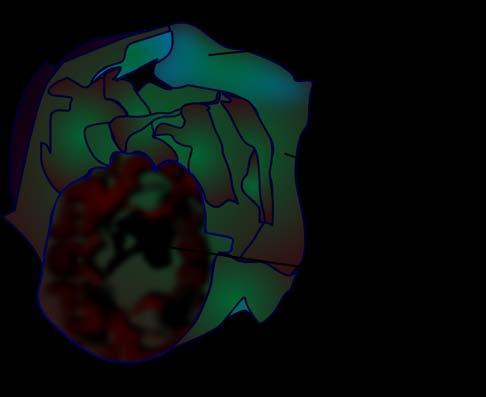what shows a very large multilocular cyst without papillae?
Answer the question using a single word or phrase. Cut surface 